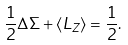Convert formula to latex. <formula><loc_0><loc_0><loc_500><loc_500>\frac { 1 } { 2 } \Delta \Sigma + \left \langle L _ { Z } \right \rangle = \frac { 1 } { 2 } .</formula> 